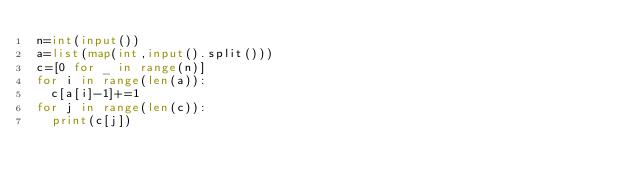Convert code to text. <code><loc_0><loc_0><loc_500><loc_500><_Python_>n=int(input())
a=list(map(int,input().split()))
c=[0 for _ in range(n)]
for i in range(len(a)):
  c[a[i]-1]+=1
for j in range(len(c)):
  print(c[j])
  
</code> 